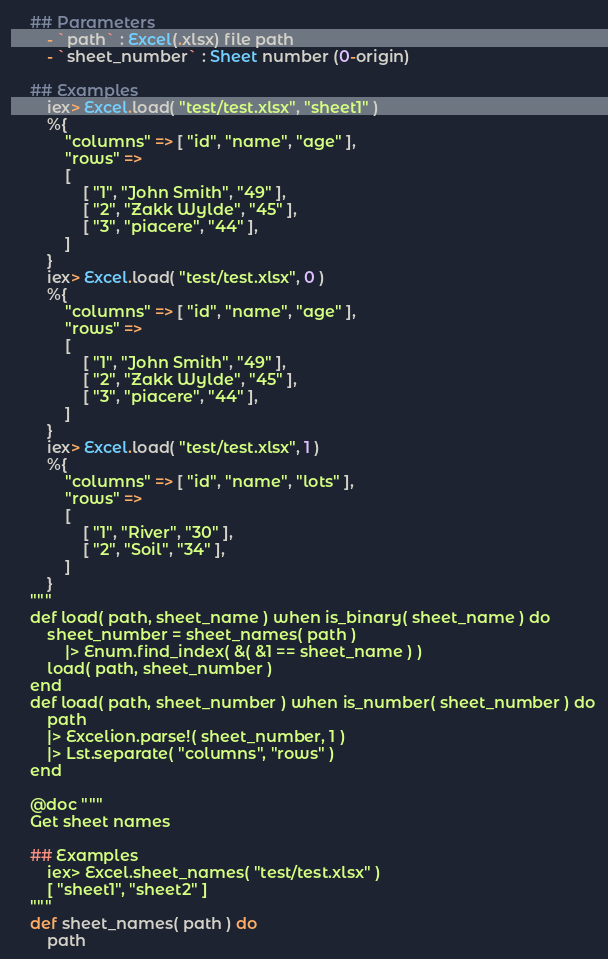Convert code to text. <code><loc_0><loc_0><loc_500><loc_500><_Elixir_>	## Parameters
		- `path` : Excel(.xlsx) file path
		- `sheet_number` : Sheet number (0-origin)

	## Examples
		iex> Excel.load( "test/test.xlsx", "sheet1" )
		%{
			"columns" => [ "id", "name", "age" ], 
			"rows" => 
			[
				[ "1", "John Smith", "49" ],
				[ "2", "Zakk Wylde", "45" ],
				[ "3", "piacere", "44" ], 
	        ] 
		}
		iex> Excel.load( "test/test.xlsx", 0 )
		%{
			"columns" => [ "id", "name", "age" ], 
			"rows" => 
			[
				[ "1", "John Smith", "49" ],
				[ "2", "Zakk Wylde", "45" ],
				[ "3", "piacere", "44" ], 
	        ] 
		}
		iex> Excel.load( "test/test.xlsx", 1 )
		%{
			"columns" => [ "id", "name", "lots" ], 
			"rows" => 
			[
				[ "1", "River", "30" ],
				[ "2", "Soil", "34" ],
			]
		}
	"""
	def load( path, sheet_name ) when is_binary( sheet_name ) do
		sheet_number = sheet_names( path ) 
			|> Enum.find_index( &( &1 == sheet_name ) )
		load( path, sheet_number )
	end
	def load( path, sheet_number ) when is_number( sheet_number ) do
		path
		|> Excelion.parse!( sheet_number, 1 ) 
		|> Lst.separate( "columns", "rows" )
	end

	@doc """
	Get sheet names

	## Examples
		iex> Excel.sheet_names( "test/test.xlsx" )
		[ "sheet1", "sheet2" ]
	"""
	def sheet_names( path ) do
		path</code> 